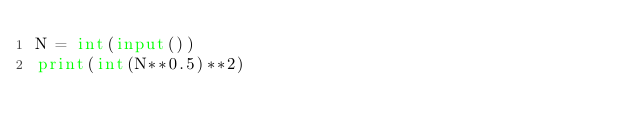Convert code to text. <code><loc_0><loc_0><loc_500><loc_500><_Python_>N = int(input())
print(int(N**0.5)**2)</code> 